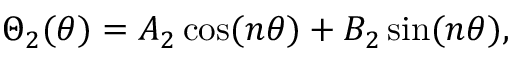<formula> <loc_0><loc_0><loc_500><loc_500>\Theta _ { 2 } ( \theta ) = A _ { 2 } \cos ( n \theta ) + B _ { 2 } \sin ( n \theta ) ,</formula> 